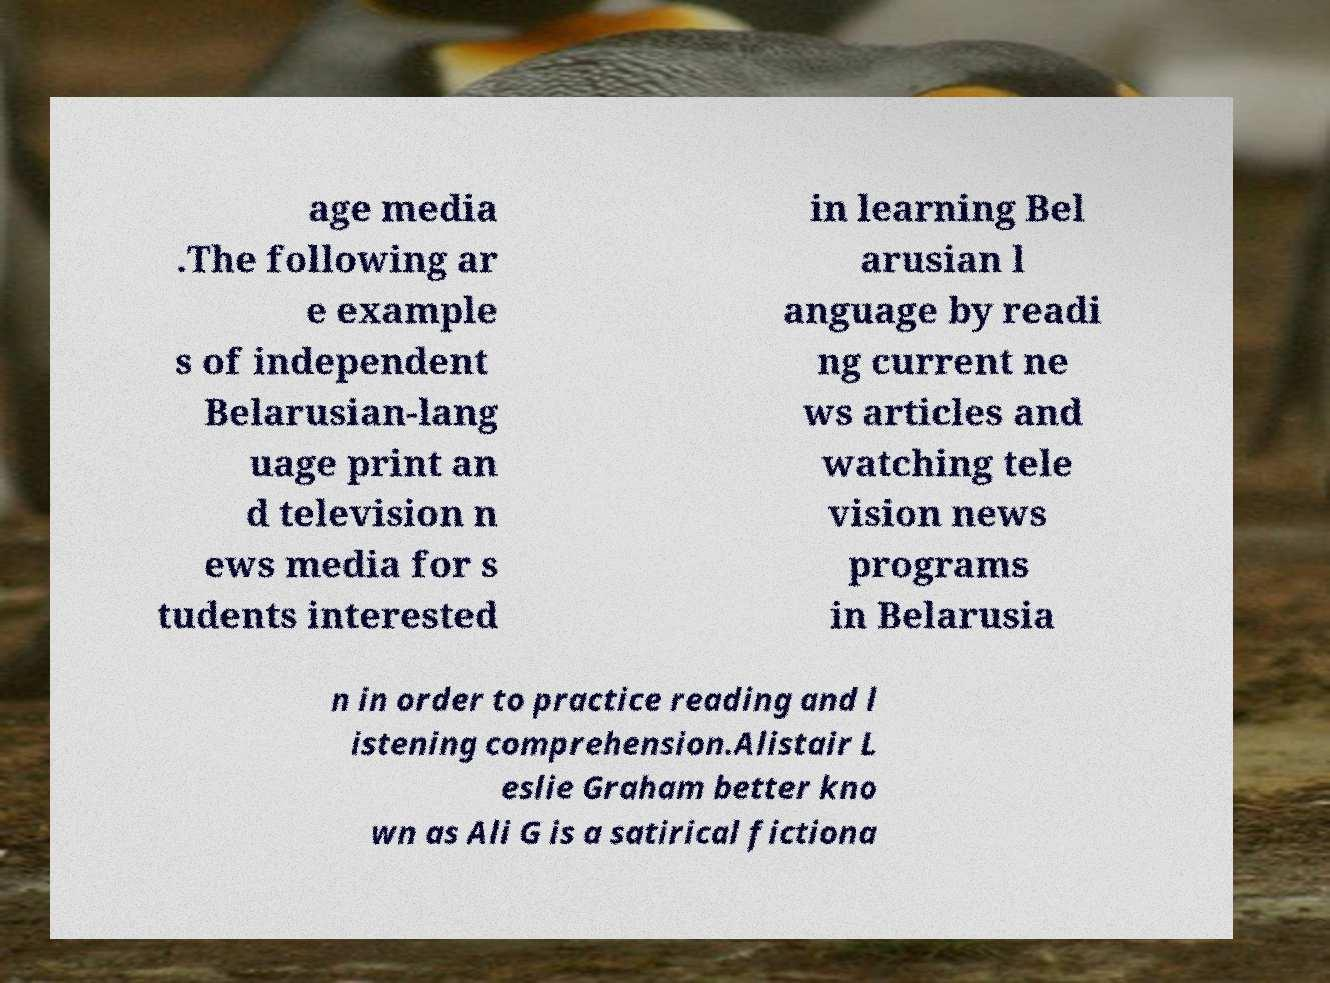Could you assist in decoding the text presented in this image and type it out clearly? age media .The following ar e example s of independent Belarusian-lang uage print an d television n ews media for s tudents interested in learning Bel arusian l anguage by readi ng current ne ws articles and watching tele vision news programs in Belarusia n in order to practice reading and l istening comprehension.Alistair L eslie Graham better kno wn as Ali G is a satirical fictiona 